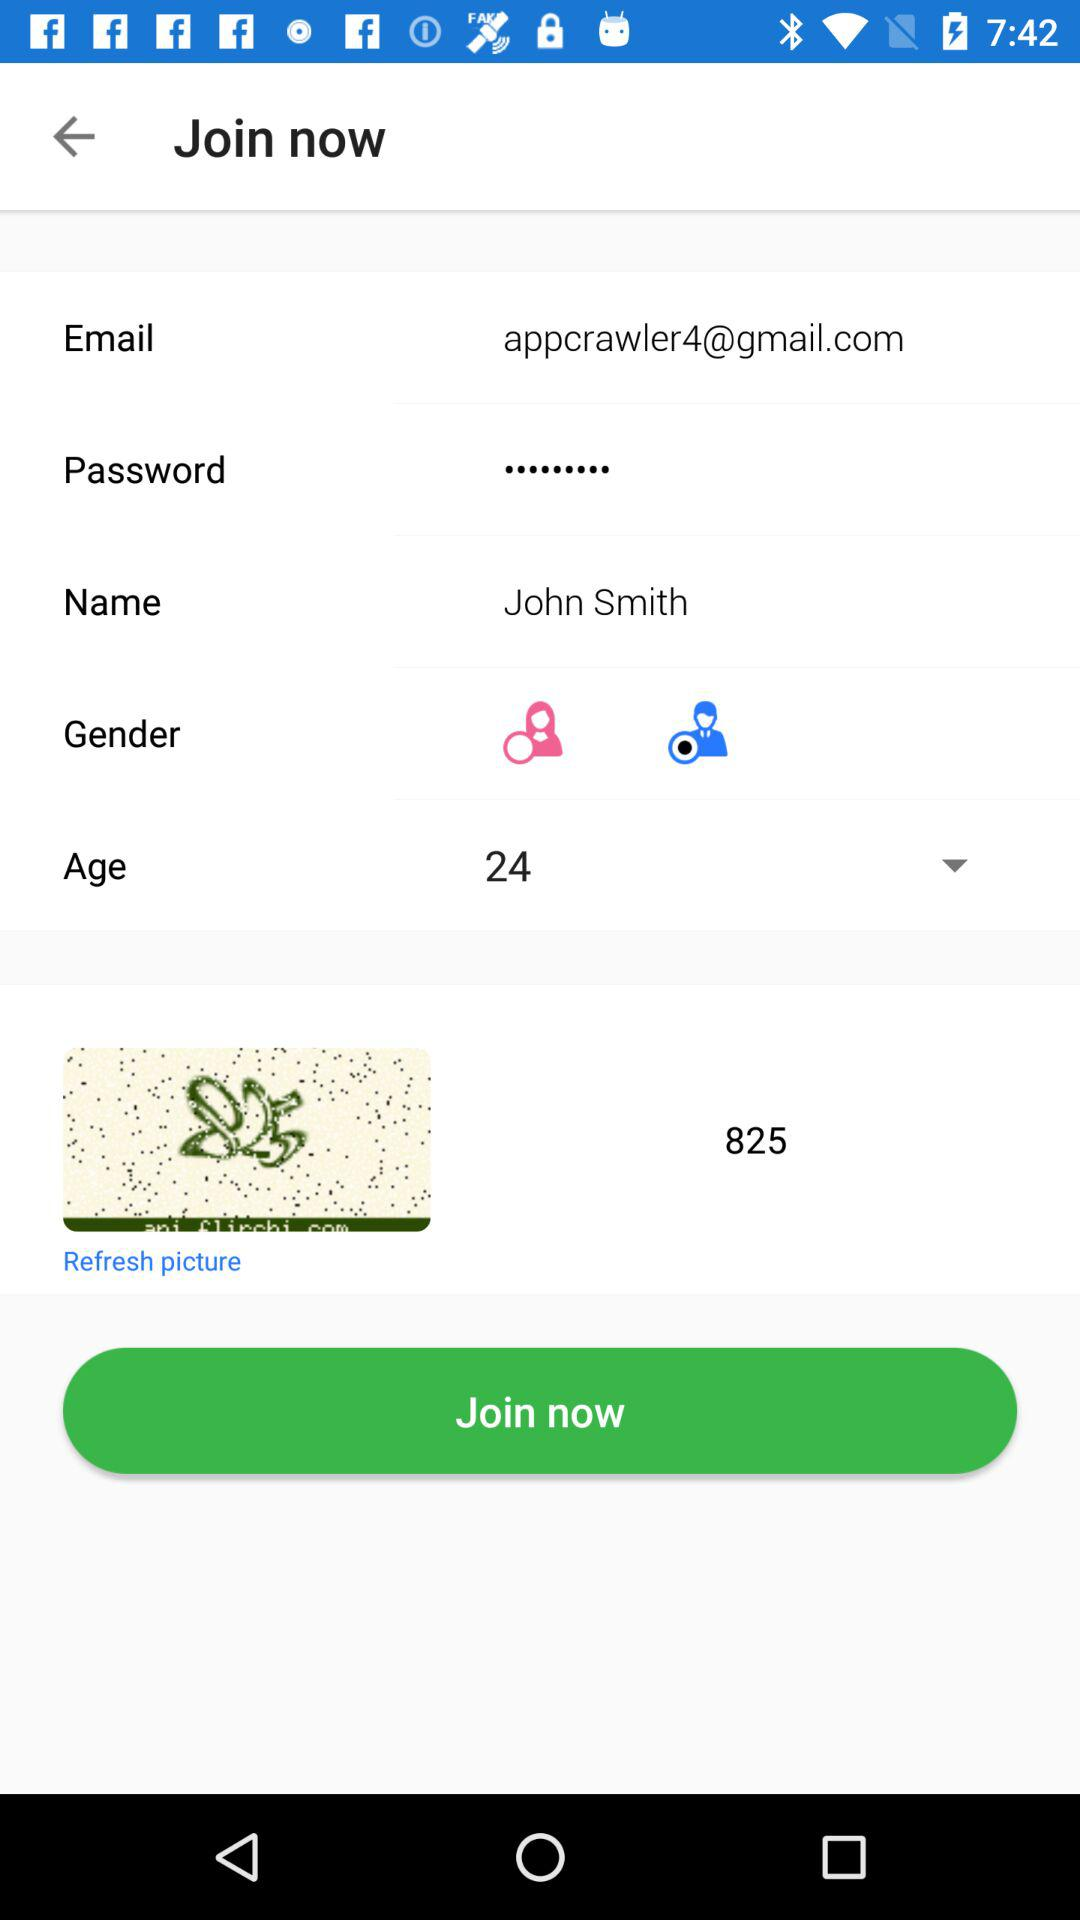What gender is selected? The selected gender is "male". 